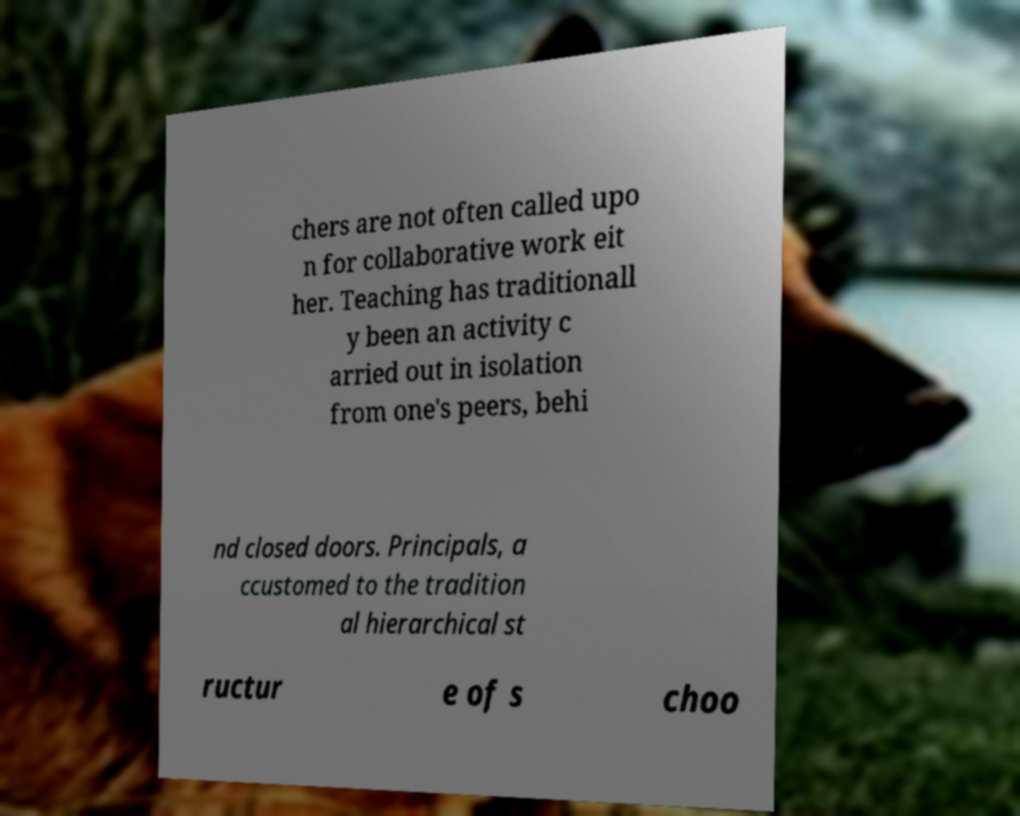Please read and relay the text visible in this image. What does it say? chers are not often called upo n for collaborative work eit her. Teaching has traditionall y been an activity c arried out in isolation from one's peers, behi nd closed doors. Principals, a ccustomed to the tradition al hierarchical st ructur e of s choo 